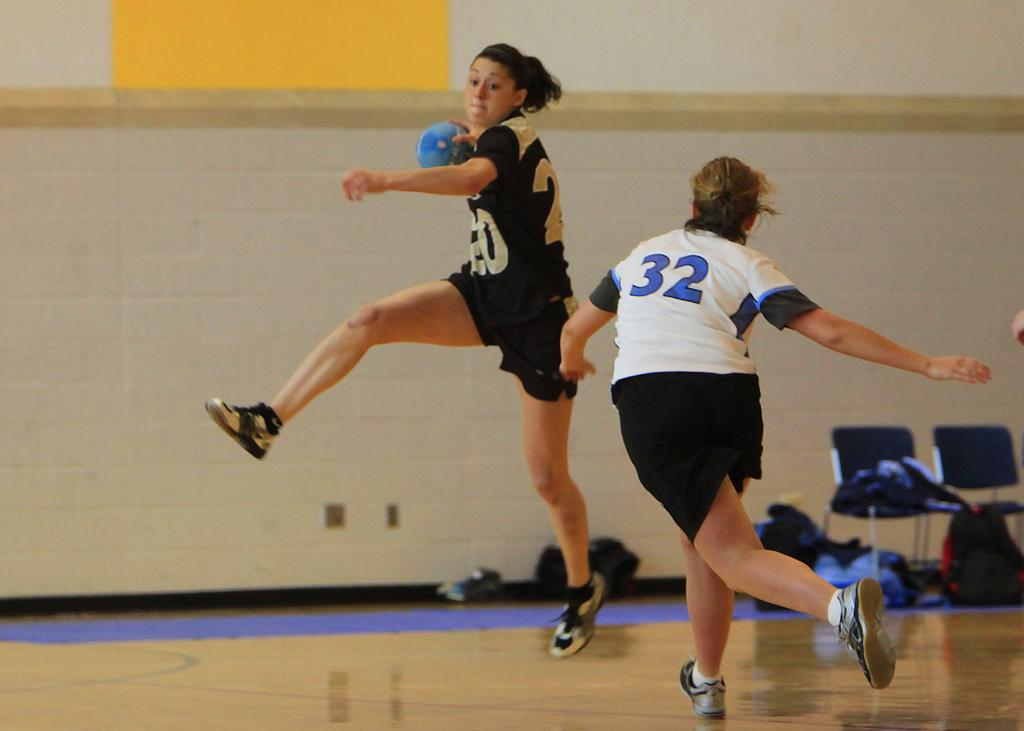What is the surface on which the women are standing in the image? There is a floor in the image. How many women are present in the image? There are two women in the image. What activity are the women engaged in? The women are playing a game. What can be seen in the background of the image? There are chairs and bags in the background of the image. What is the structure that separates the room from the outside in the image? There is a wall in the image. What type of apparatus is used by the women to play the game in the image? There is no specific apparatus mentioned in the image; the women are simply playing a game. What disease is being treated by the women in the image? There is no indication of any disease or medical treatment in the image; the women are playing a game. 